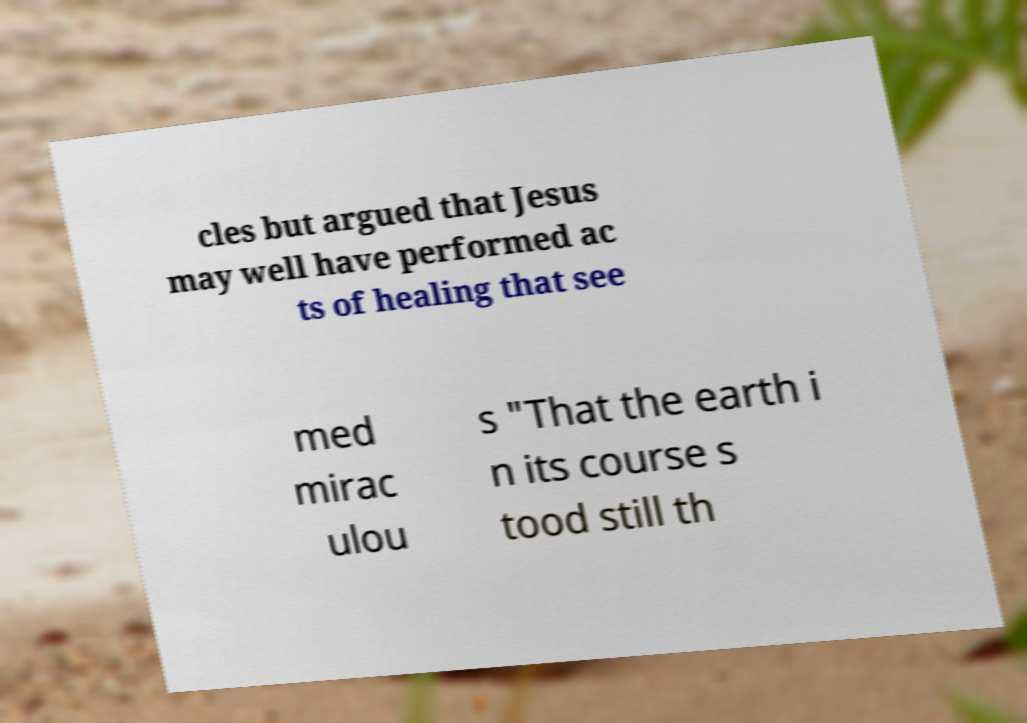Please identify and transcribe the text found in this image. cles but argued that Jesus may well have performed ac ts of healing that see med mirac ulou s "That the earth i n its course s tood still th 